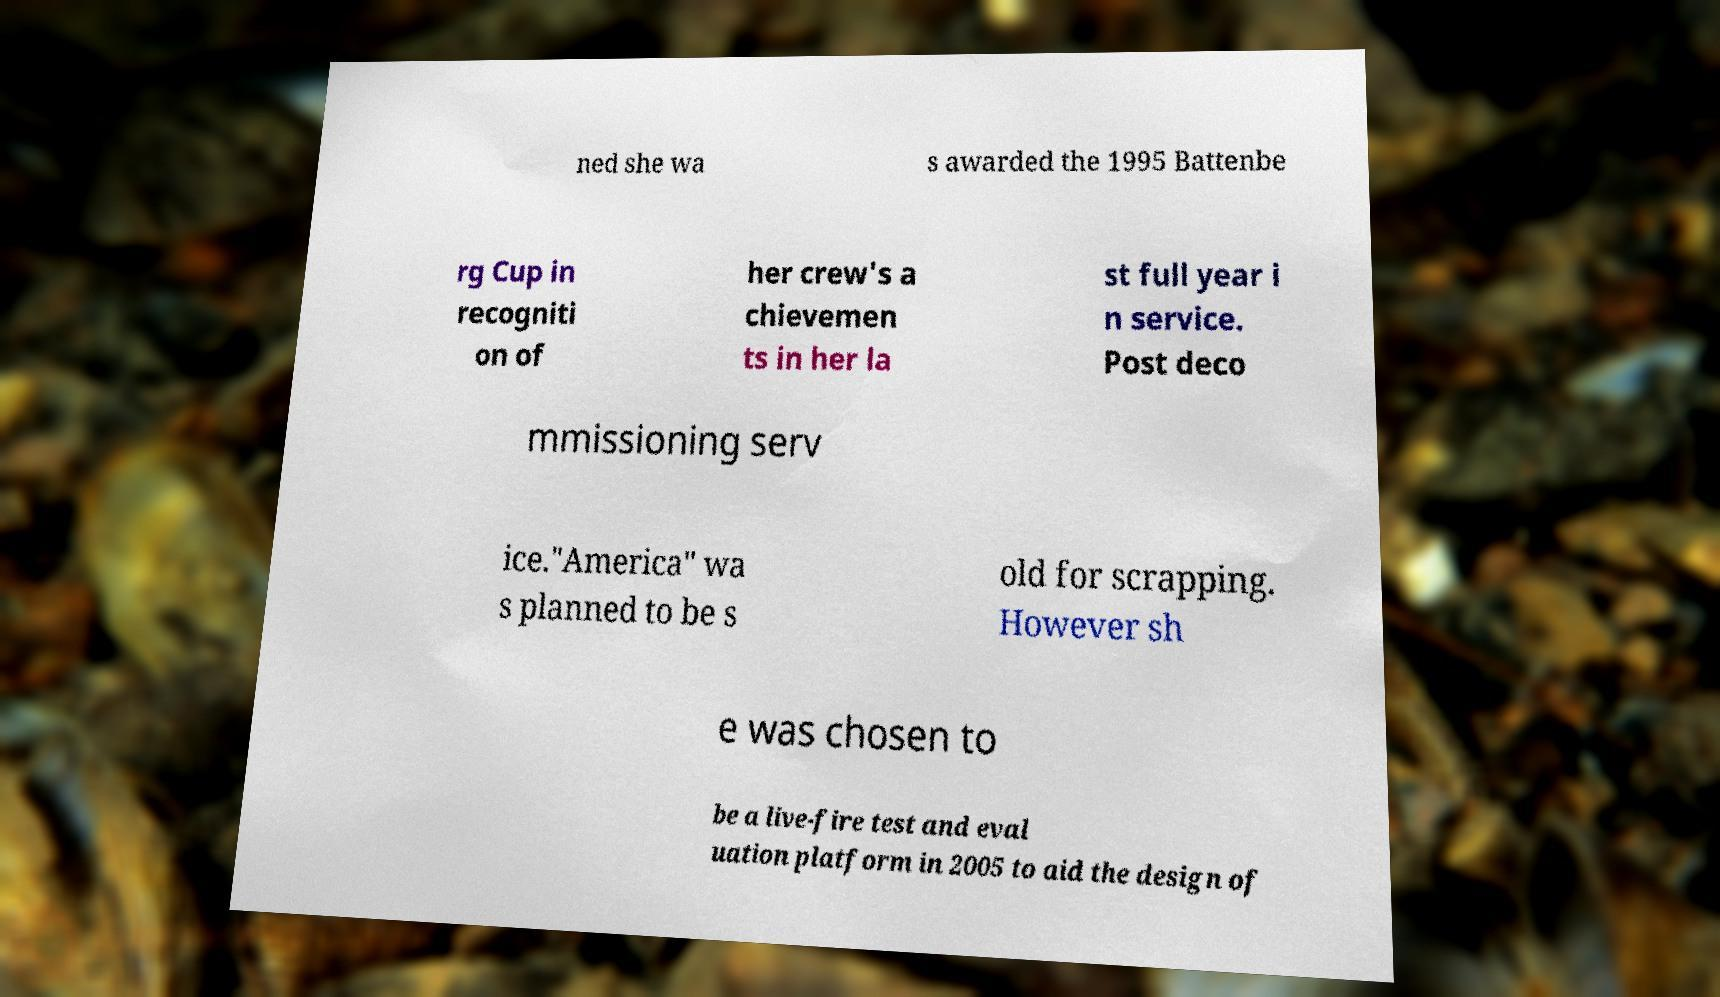Can you accurately transcribe the text from the provided image for me? ned she wa s awarded the 1995 Battenbe rg Cup in recogniti on of her crew's a chievemen ts in her la st full year i n service. Post deco mmissioning serv ice."America" wa s planned to be s old for scrapping. However sh e was chosen to be a live-fire test and eval uation platform in 2005 to aid the design of 